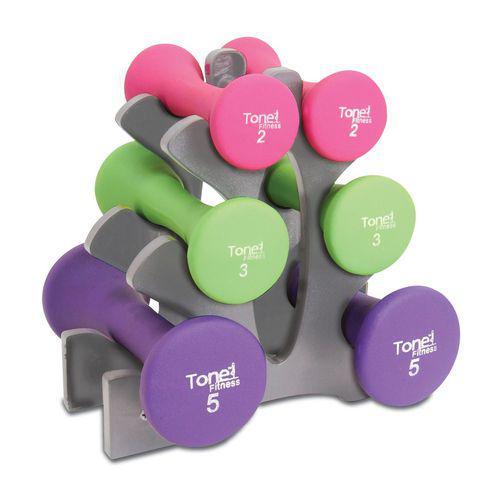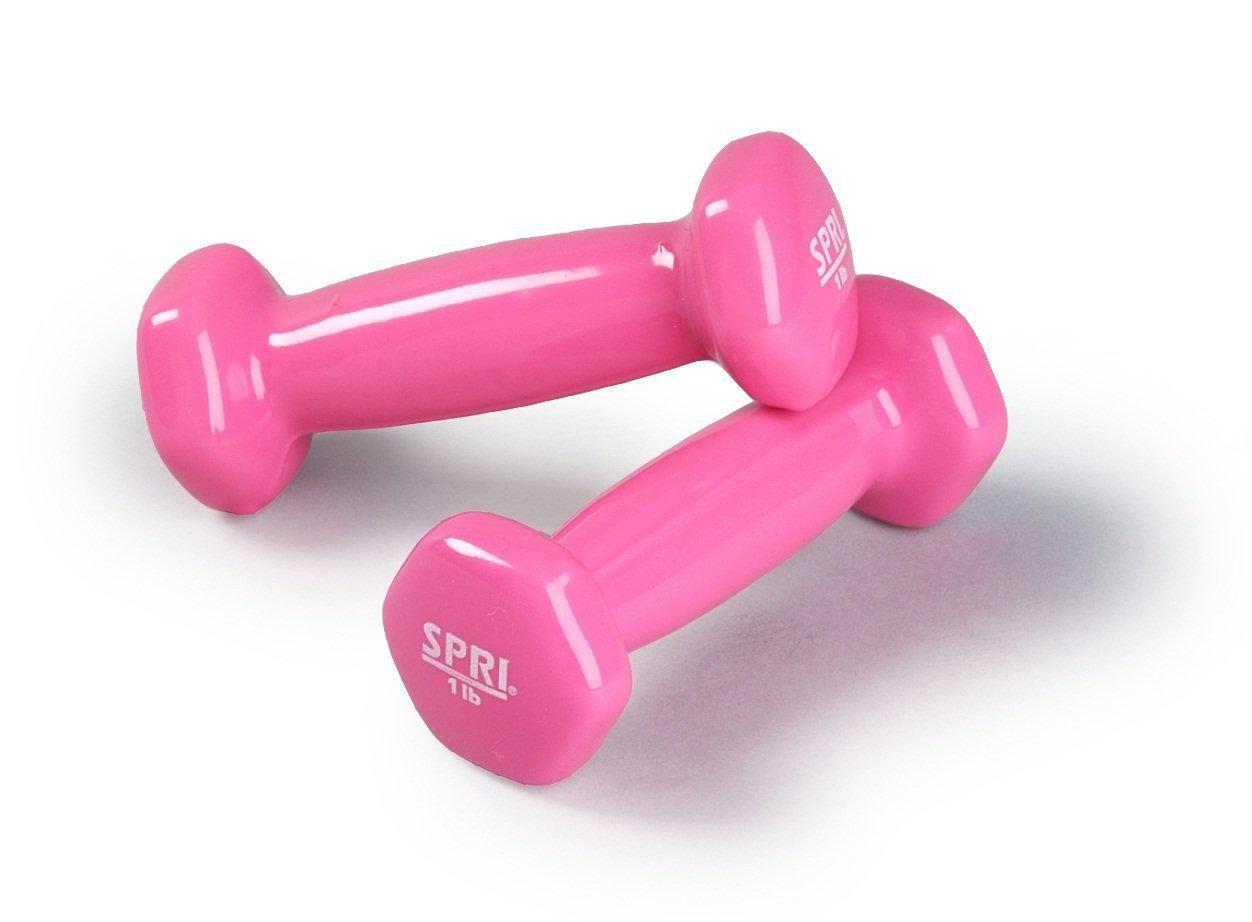The first image is the image on the left, the second image is the image on the right. Assess this claim about the two images: "The right image contains two small pink exercise weights.". Correct or not? Answer yes or no. Yes. The first image is the image on the left, the second image is the image on the right. Examine the images to the left and right. Is the description "The right image shows a pair of pink free weights with one weight resting slightly atop the other" accurate? Answer yes or no. Yes. 